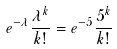Convert formula to latex. <formula><loc_0><loc_0><loc_500><loc_500>e ^ { - \lambda } \frac { \lambda ^ { k } } { k ! } = e ^ { - 5 } \frac { 5 ^ { k } } { k ! }</formula> 